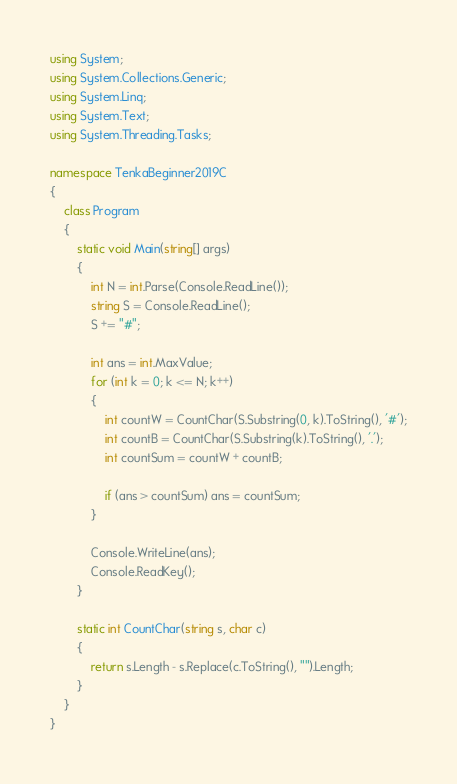Convert code to text. <code><loc_0><loc_0><loc_500><loc_500><_C#_>using System;
using System.Collections.Generic;
using System.Linq;
using System.Text;
using System.Threading.Tasks;

namespace TenkaBeginner2019C
{
    class Program
    {
        static void Main(string[] args)
        {
            int N = int.Parse(Console.ReadLine());
            string S = Console.ReadLine();
            S += "#";

            int ans = int.MaxValue;
            for (int k = 0; k <= N; k++)
            {
                int countW = CountChar(S.Substring(0, k).ToString(), '#');
                int countB = CountChar(S.Substring(k).ToString(), '.');
                int countSum = countW + countB;

                if (ans > countSum) ans = countSum;
            }

            Console.WriteLine(ans);
            Console.ReadKey();
        }

        static int CountChar(string s, char c)
        {
            return s.Length - s.Replace(c.ToString(), "").Length;
        }
    }
}
</code> 